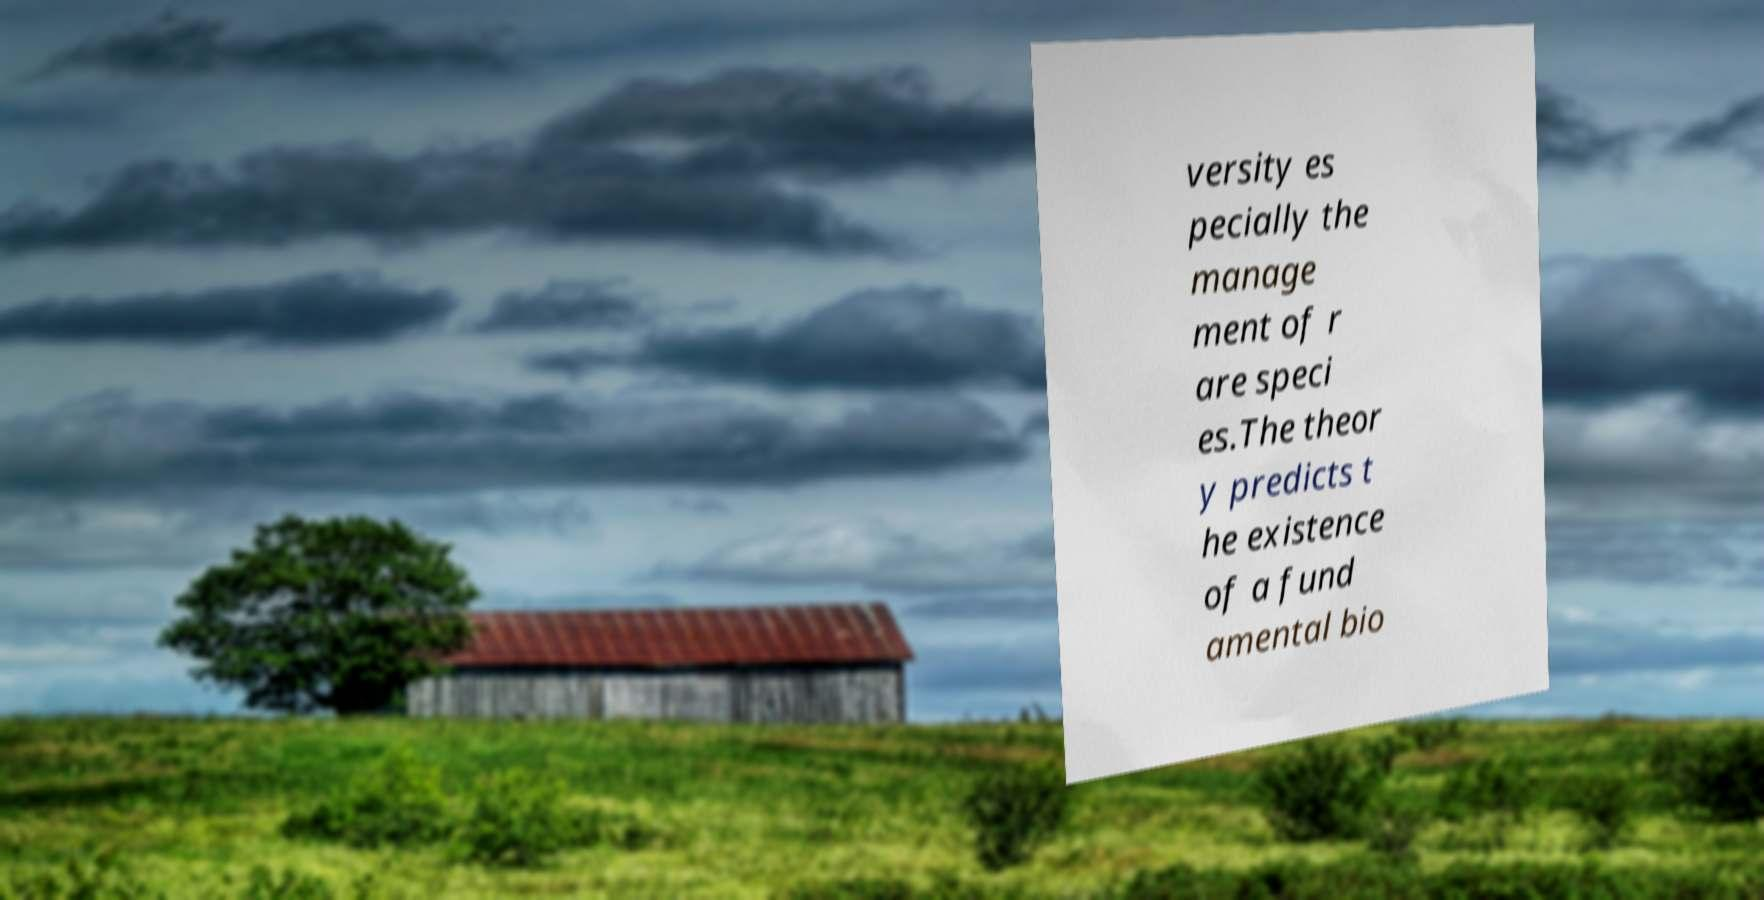Please read and relay the text visible in this image. What does it say? versity es pecially the manage ment of r are speci es.The theor y predicts t he existence of a fund amental bio 